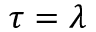Convert formula to latex. <formula><loc_0><loc_0><loc_500><loc_500>\tau = \lambda</formula> 